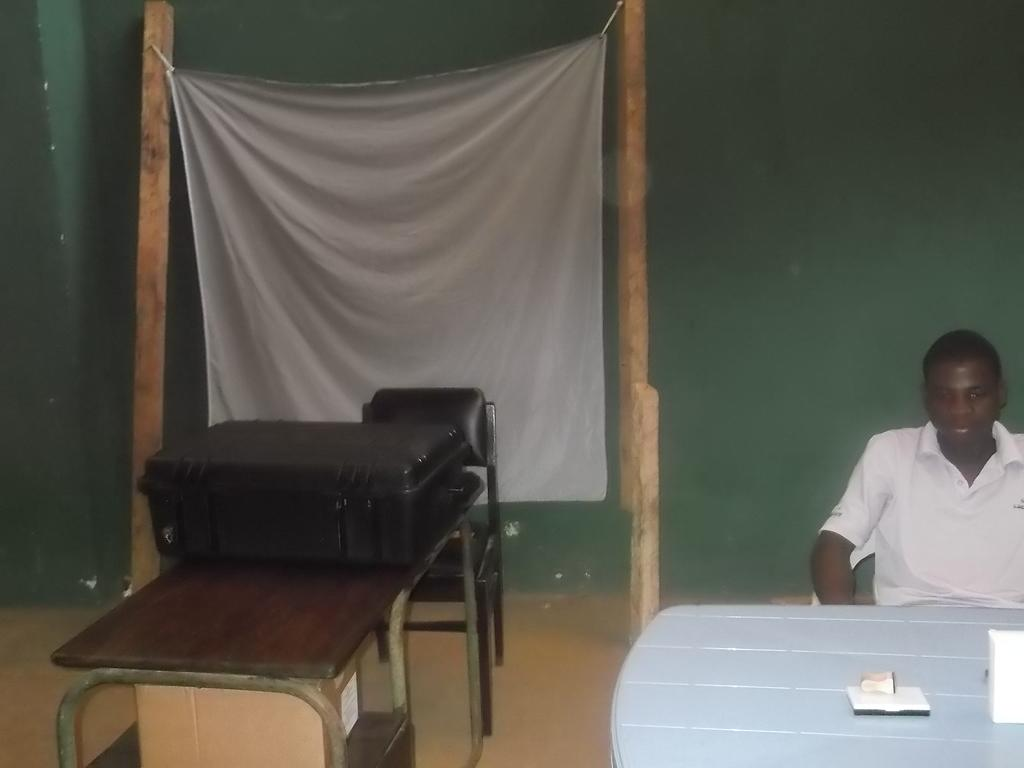What is present in the image that can be used for covering or cleaning? There is a cloth in the image that can be used for covering or cleaning. What is the man in the image doing? The man in the image is sitting on chairs. What is the main piece of furniture in the image? There is a table in the image. What object is placed on the table? There is a suitcase on the table in the image. What type of quill is the fireman using to write on the quince in the image? There is no quill, fireman, or quince present in the image. 